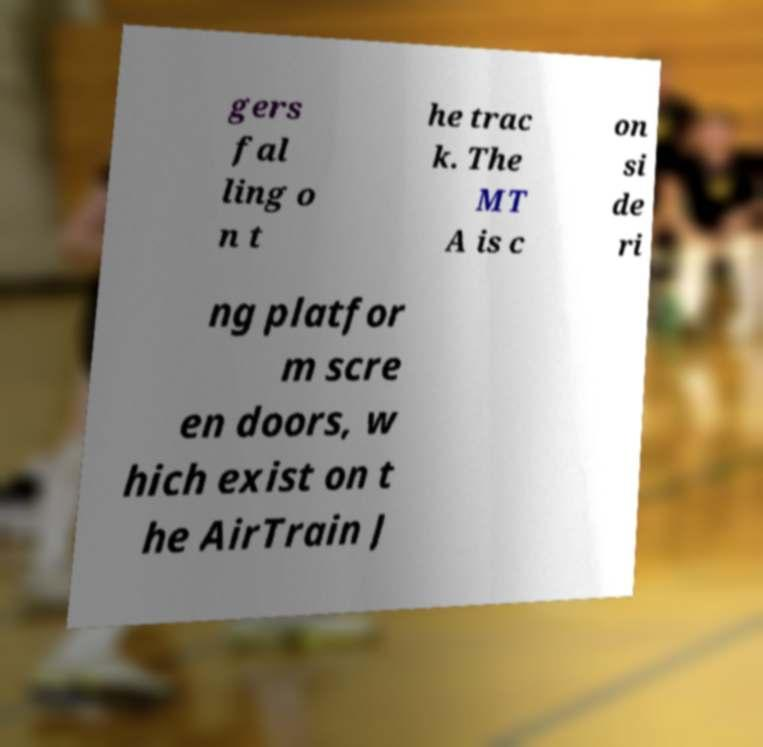Please identify and transcribe the text found in this image. gers fal ling o n t he trac k. The MT A is c on si de ri ng platfor m scre en doors, w hich exist on t he AirTrain J 